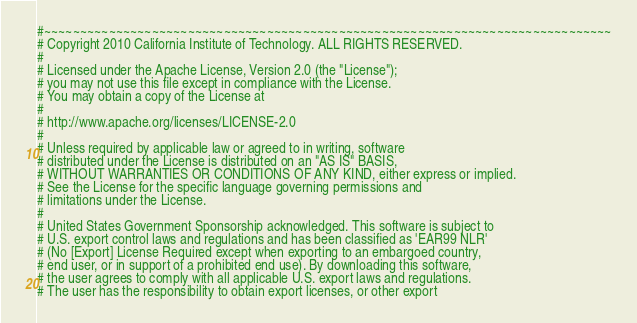Convert code to text. <code><loc_0><loc_0><loc_500><loc_500><_Python_>#~~~~~~~~~~~~~~~~~~~~~~~~~~~~~~~~~~~~~~~~~~~~~~~~~~~~~~~~~~~~~~~~~~~~~~~~~~~~~~~
# Copyright 2010 California Institute of Technology. ALL RIGHTS RESERVED.
# 
# Licensed under the Apache License, Version 2.0 (the "License");
# you may not use this file except in compliance with the License.
# You may obtain a copy of the License at
# 
# http://www.apache.org/licenses/LICENSE-2.0
# 
# Unless required by applicable law or agreed to in writing, software
# distributed under the License is distributed on an "AS IS" BASIS,
# WITHOUT WARRANTIES OR CONDITIONS OF ANY KIND, either express or implied.
# See the License for the specific language governing permissions and
# limitations under the License.
# 
# United States Government Sponsorship acknowledged. This software is subject to
# U.S. export control laws and regulations and has been classified as 'EAR99 NLR'
# (No [Export] License Required except when exporting to an embargoed country,
# end user, or in support of a prohibited end use). By downloading this software,
# the user agrees to comply with all applicable U.S. export laws and regulations.
# The user has the responsibility to obtain export licenses, or other export</code> 